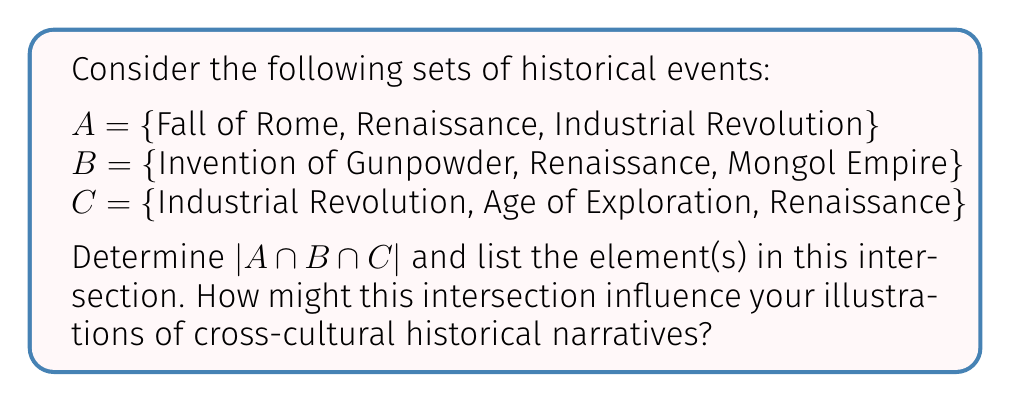Could you help me with this problem? To solve this problem, we need to find the intersection of all three sets A, B, and C. Let's approach this step-by-step:

1) First, let's identify the elements that appear in all three sets:

   A = {Fall of Rome, Renaissance, Industrial Revolution}
   B = {Invention of Gunpowder, Renaissance, Mongol Empire}
   C = {Industrial Revolution, Age of Exploration, Renaissance}

2) We can see that "Renaissance" appears in all three sets.

3) No other element appears in all three sets:
   - "Industrial Revolution" appears in A and C, but not in B.
   - "Fall of Rome" appears only in A.
   - "Invention of Gunpowder" and "Mongol Empire" appear only in B.
   - "Age of Exploration" appears only in C.

4) Therefore, the intersection of A, B, and C is:

   $A \cap B \cap C = \text{\{Renaissance\}}$

5) The cardinality of this intersection, denoted as $|A \cap B \cap C|$, is the number of elements in the set. In this case, there is only one element.

   $|A \cap B \cap C| = 1$

For a speculative historic researcher creating illustrations, this intersection suggests that the Renaissance is a pivotal event that connects various civilizations and time periods. It could serve as a central theme or connecting element in illustrations depicting cross-cultural historical narratives.
Answer: $|A \cap B \cap C| = 1$
The element in the intersection is {Renaissance} 